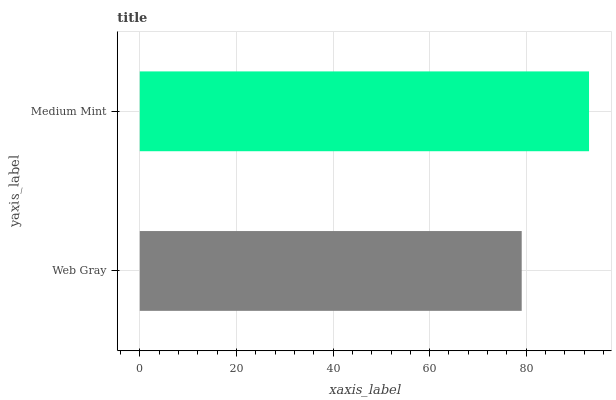Is Web Gray the minimum?
Answer yes or no. Yes. Is Medium Mint the maximum?
Answer yes or no. Yes. Is Medium Mint the minimum?
Answer yes or no. No. Is Medium Mint greater than Web Gray?
Answer yes or no. Yes. Is Web Gray less than Medium Mint?
Answer yes or no. Yes. Is Web Gray greater than Medium Mint?
Answer yes or no. No. Is Medium Mint less than Web Gray?
Answer yes or no. No. Is Medium Mint the high median?
Answer yes or no. Yes. Is Web Gray the low median?
Answer yes or no. Yes. Is Web Gray the high median?
Answer yes or no. No. Is Medium Mint the low median?
Answer yes or no. No. 